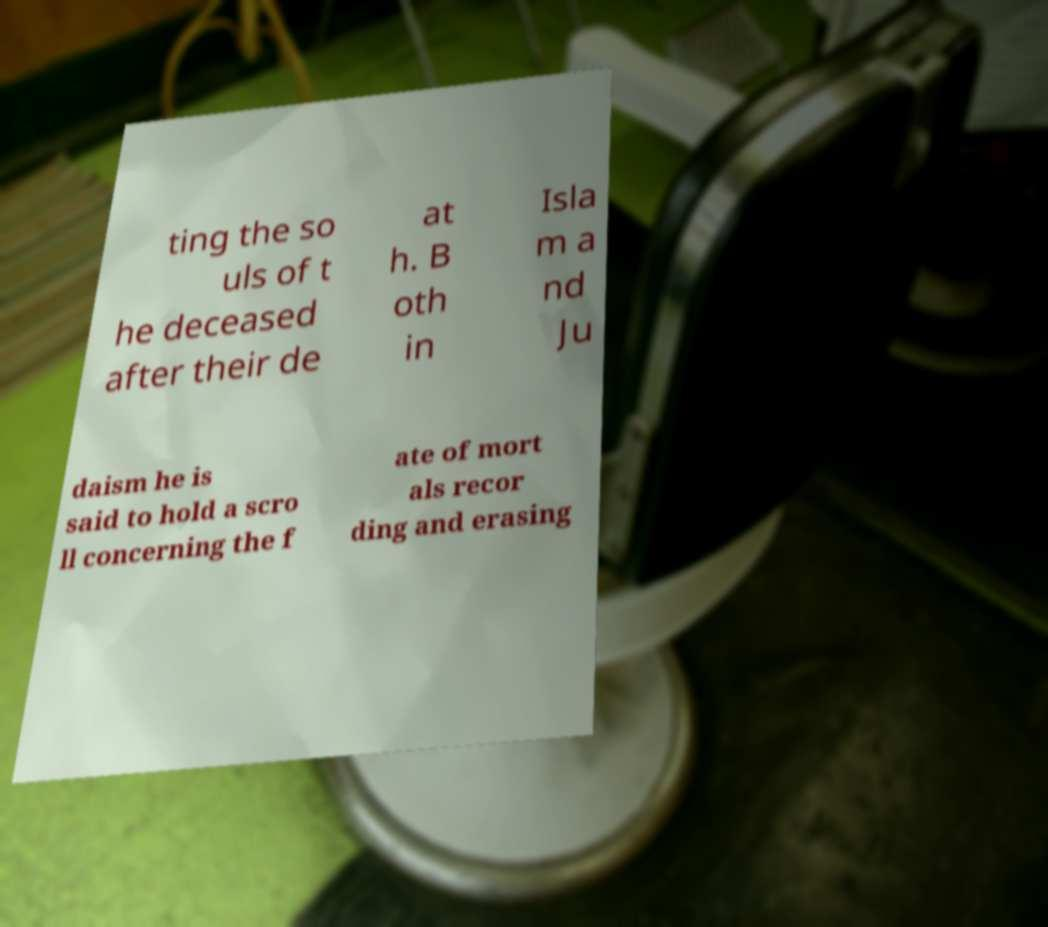What messages or text are displayed in this image? I need them in a readable, typed format. ting the so uls of t he deceased after their de at h. B oth in Isla m a nd Ju daism he is said to hold a scro ll concerning the f ate of mort als recor ding and erasing 